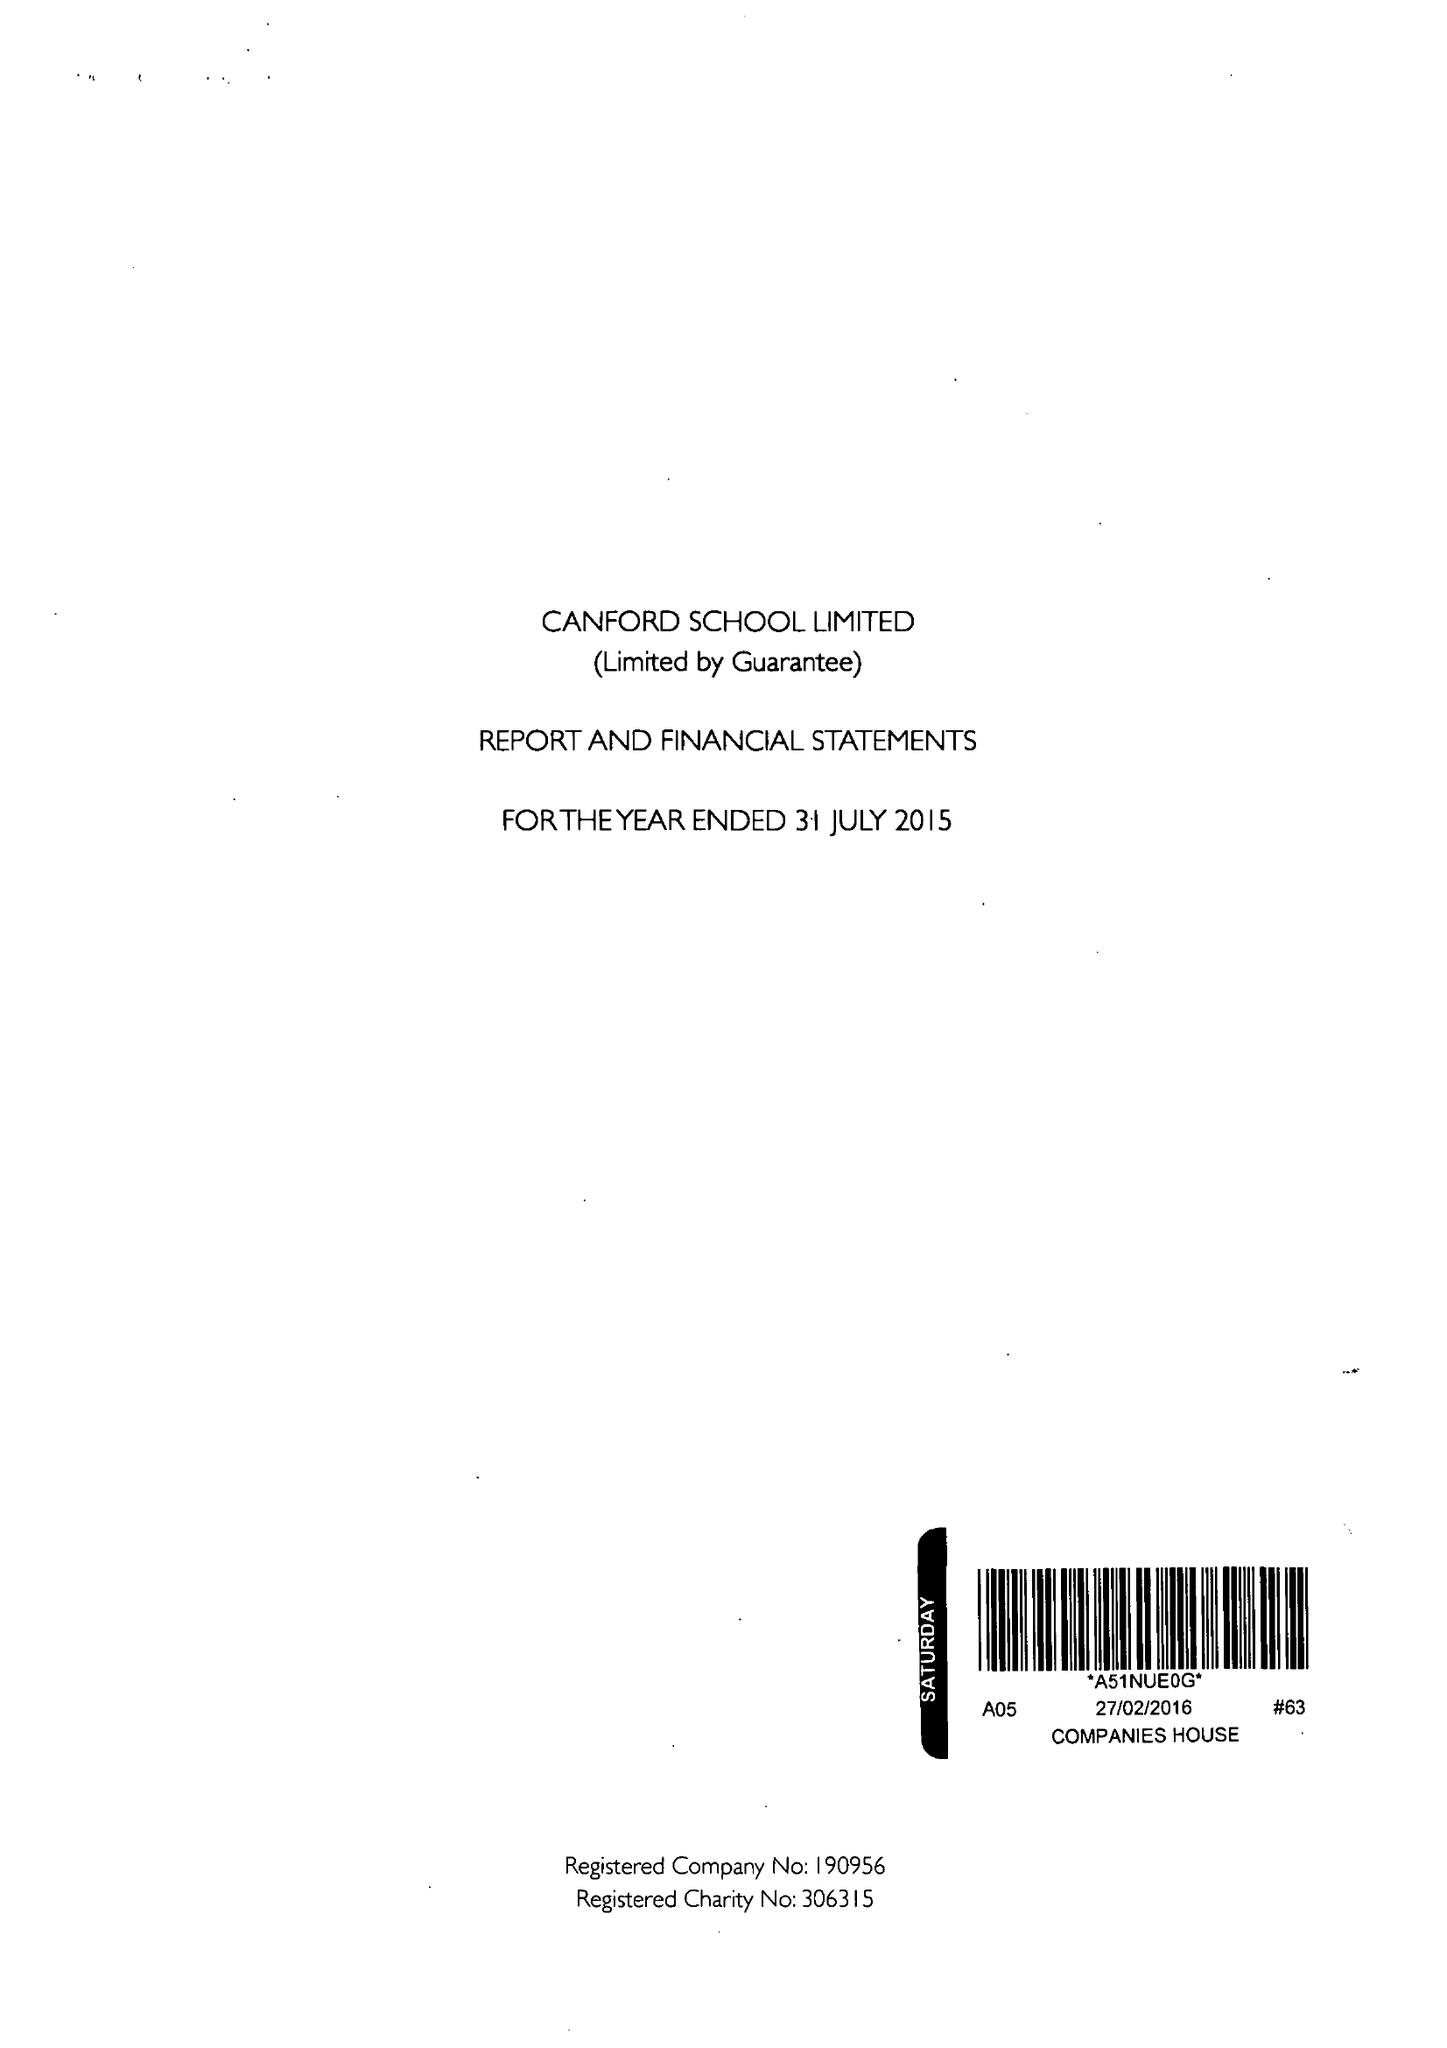What is the value for the spending_annually_in_british_pounds?
Answer the question using a single word or phrase. 17493163.00 